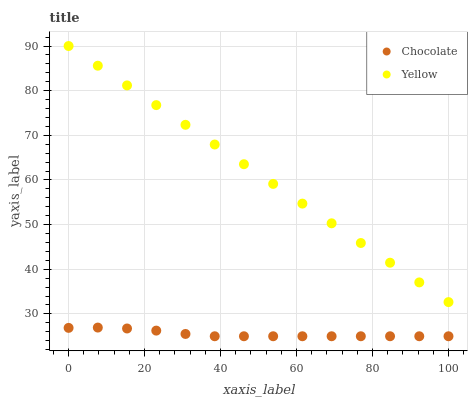Does Chocolate have the minimum area under the curve?
Answer yes or no. Yes. Does Yellow have the maximum area under the curve?
Answer yes or no. Yes. Does Chocolate have the maximum area under the curve?
Answer yes or no. No. Is Yellow the smoothest?
Answer yes or no. Yes. Is Chocolate the roughest?
Answer yes or no. Yes. Is Chocolate the smoothest?
Answer yes or no. No. Does Chocolate have the lowest value?
Answer yes or no. Yes. Does Yellow have the highest value?
Answer yes or no. Yes. Does Chocolate have the highest value?
Answer yes or no. No. Is Chocolate less than Yellow?
Answer yes or no. Yes. Is Yellow greater than Chocolate?
Answer yes or no. Yes. Does Chocolate intersect Yellow?
Answer yes or no. No. 